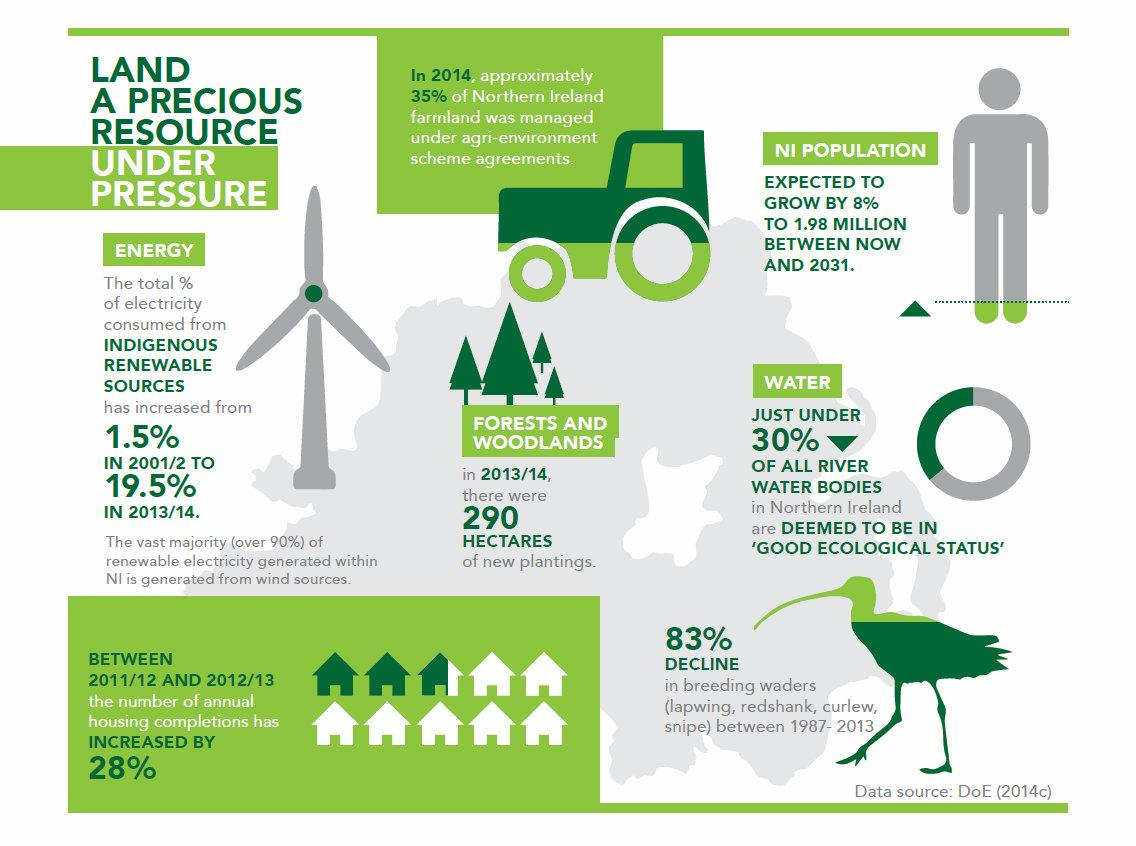Give some essential details in this illustration. From 2001/2 to 2013/14, there was a 18% increase in the total percentage of electricity consumed from indigenous renewable sources. The majority of renewable electricity generated in Northern Ireland comes from wind power. In the 2013/2014 fiscal year, woodlands and forests underwent an expansion of approximately 290 hectares. The expected growth in population in Northern Ireland by 2031 is projected to be 1.98 million. 